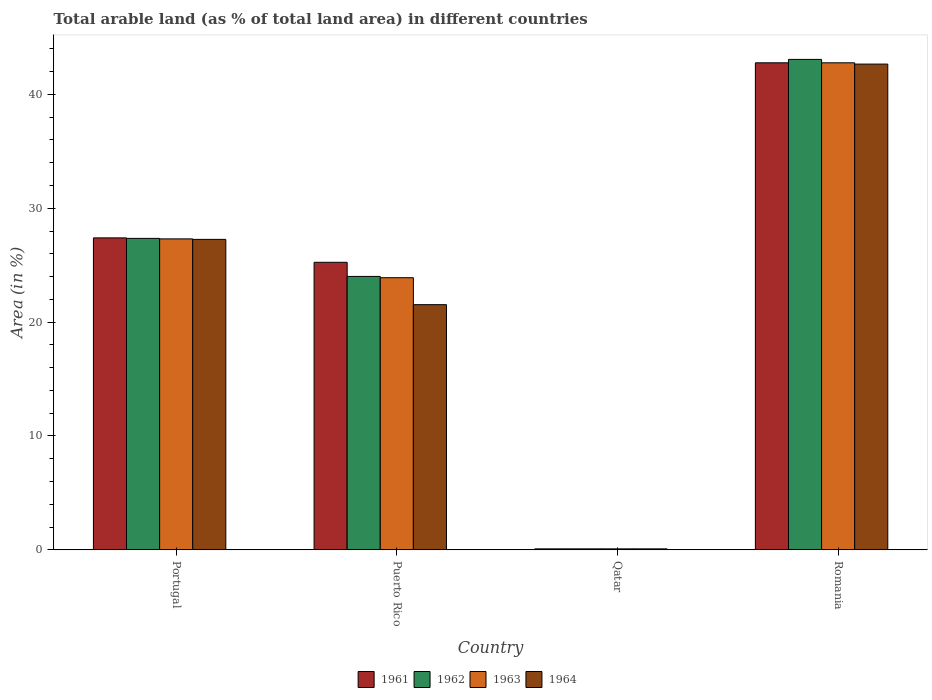How many different coloured bars are there?
Your answer should be compact. 4. How many groups of bars are there?
Provide a succinct answer. 4. Are the number of bars per tick equal to the number of legend labels?
Ensure brevity in your answer.  Yes. Are the number of bars on each tick of the X-axis equal?
Ensure brevity in your answer.  Yes. How many bars are there on the 1st tick from the left?
Give a very brief answer. 4. In how many cases, is the number of bars for a given country not equal to the number of legend labels?
Offer a terse response. 0. What is the percentage of arable land in 1963 in Puerto Rico?
Provide a succinct answer. 23.9. Across all countries, what is the maximum percentage of arable land in 1963?
Give a very brief answer. 42.78. Across all countries, what is the minimum percentage of arable land in 1964?
Give a very brief answer. 0.09. In which country was the percentage of arable land in 1963 maximum?
Your answer should be very brief. Romania. In which country was the percentage of arable land in 1964 minimum?
Offer a terse response. Qatar. What is the total percentage of arable land in 1963 in the graph?
Provide a short and direct response. 94.07. What is the difference between the percentage of arable land in 1962 in Portugal and that in Puerto Rico?
Your answer should be compact. 3.34. What is the difference between the percentage of arable land in 1961 in Puerto Rico and the percentage of arable land in 1963 in Portugal?
Provide a short and direct response. -2.06. What is the average percentage of arable land in 1963 per country?
Keep it short and to the point. 23.52. What is the difference between the percentage of arable land of/in 1961 and percentage of arable land of/in 1964 in Puerto Rico?
Make the answer very short. 3.72. In how many countries, is the percentage of arable land in 1963 greater than 34 %?
Offer a very short reply. 1. What is the ratio of the percentage of arable land in 1963 in Portugal to that in Qatar?
Your response must be concise. 317.09. Is the percentage of arable land in 1962 in Puerto Rico less than that in Qatar?
Your answer should be compact. No. Is the difference between the percentage of arable land in 1961 in Portugal and Romania greater than the difference between the percentage of arable land in 1964 in Portugal and Romania?
Give a very brief answer. Yes. What is the difference between the highest and the second highest percentage of arable land in 1963?
Provide a short and direct response. 15.46. What is the difference between the highest and the lowest percentage of arable land in 1963?
Provide a succinct answer. 42.69. In how many countries, is the percentage of arable land in 1962 greater than the average percentage of arable land in 1962 taken over all countries?
Give a very brief answer. 3. Is it the case that in every country, the sum of the percentage of arable land in 1964 and percentage of arable land in 1962 is greater than the sum of percentage of arable land in 1963 and percentage of arable land in 1961?
Keep it short and to the point. No. What does the 4th bar from the left in Qatar represents?
Your response must be concise. 1964. How many countries are there in the graph?
Ensure brevity in your answer.  4. What is the difference between two consecutive major ticks on the Y-axis?
Make the answer very short. 10. Are the values on the major ticks of Y-axis written in scientific E-notation?
Your answer should be compact. No. Does the graph contain any zero values?
Offer a terse response. No. Does the graph contain grids?
Keep it short and to the point. No. How are the legend labels stacked?
Offer a terse response. Horizontal. What is the title of the graph?
Make the answer very short. Total arable land (as % of total land area) in different countries. What is the label or title of the X-axis?
Your answer should be compact. Country. What is the label or title of the Y-axis?
Your response must be concise. Area (in %). What is the Area (in %) in 1961 in Portugal?
Give a very brief answer. 27.4. What is the Area (in %) in 1962 in Portugal?
Ensure brevity in your answer.  27.36. What is the Area (in %) of 1963 in Portugal?
Provide a short and direct response. 27.31. What is the Area (in %) of 1964 in Portugal?
Offer a terse response. 27.27. What is the Area (in %) in 1961 in Puerto Rico?
Provide a succinct answer. 25.25. What is the Area (in %) of 1962 in Puerto Rico?
Your response must be concise. 24.01. What is the Area (in %) of 1963 in Puerto Rico?
Offer a terse response. 23.9. What is the Area (in %) in 1964 in Puerto Rico?
Provide a succinct answer. 21.53. What is the Area (in %) of 1961 in Qatar?
Make the answer very short. 0.09. What is the Area (in %) of 1962 in Qatar?
Your answer should be compact. 0.09. What is the Area (in %) of 1963 in Qatar?
Keep it short and to the point. 0.09. What is the Area (in %) in 1964 in Qatar?
Provide a succinct answer. 0.09. What is the Area (in %) of 1961 in Romania?
Make the answer very short. 42.78. What is the Area (in %) of 1962 in Romania?
Provide a succinct answer. 43.08. What is the Area (in %) of 1963 in Romania?
Offer a terse response. 42.78. What is the Area (in %) of 1964 in Romania?
Your answer should be very brief. 42.66. Across all countries, what is the maximum Area (in %) in 1961?
Your answer should be compact. 42.78. Across all countries, what is the maximum Area (in %) in 1962?
Provide a short and direct response. 43.08. Across all countries, what is the maximum Area (in %) in 1963?
Offer a very short reply. 42.78. Across all countries, what is the maximum Area (in %) of 1964?
Keep it short and to the point. 42.66. Across all countries, what is the minimum Area (in %) in 1961?
Ensure brevity in your answer.  0.09. Across all countries, what is the minimum Area (in %) in 1962?
Provide a succinct answer. 0.09. Across all countries, what is the minimum Area (in %) in 1963?
Provide a succinct answer. 0.09. Across all countries, what is the minimum Area (in %) of 1964?
Provide a succinct answer. 0.09. What is the total Area (in %) of 1961 in the graph?
Your answer should be very brief. 95.51. What is the total Area (in %) in 1962 in the graph?
Make the answer very short. 94.53. What is the total Area (in %) in 1963 in the graph?
Make the answer very short. 94.07. What is the total Area (in %) in 1964 in the graph?
Your answer should be very brief. 91.55. What is the difference between the Area (in %) in 1961 in Portugal and that in Puerto Rico?
Make the answer very short. 2.15. What is the difference between the Area (in %) of 1962 in Portugal and that in Puerto Rico?
Offer a terse response. 3.34. What is the difference between the Area (in %) in 1963 in Portugal and that in Puerto Rico?
Make the answer very short. 3.41. What is the difference between the Area (in %) in 1964 in Portugal and that in Puerto Rico?
Provide a succinct answer. 5.73. What is the difference between the Area (in %) of 1961 in Portugal and that in Qatar?
Keep it short and to the point. 27.31. What is the difference between the Area (in %) of 1962 in Portugal and that in Qatar?
Your answer should be very brief. 27.27. What is the difference between the Area (in %) in 1963 in Portugal and that in Qatar?
Offer a terse response. 27.23. What is the difference between the Area (in %) in 1964 in Portugal and that in Qatar?
Ensure brevity in your answer.  27.18. What is the difference between the Area (in %) of 1961 in Portugal and that in Romania?
Your response must be concise. -15.38. What is the difference between the Area (in %) in 1962 in Portugal and that in Romania?
Offer a very short reply. -15.72. What is the difference between the Area (in %) in 1963 in Portugal and that in Romania?
Offer a very short reply. -15.46. What is the difference between the Area (in %) in 1964 in Portugal and that in Romania?
Your answer should be very brief. -15.4. What is the difference between the Area (in %) of 1961 in Puerto Rico and that in Qatar?
Ensure brevity in your answer.  25.17. What is the difference between the Area (in %) in 1962 in Puerto Rico and that in Qatar?
Give a very brief answer. 23.93. What is the difference between the Area (in %) of 1963 in Puerto Rico and that in Qatar?
Give a very brief answer. 23.81. What is the difference between the Area (in %) of 1964 in Puerto Rico and that in Qatar?
Make the answer very short. 21.45. What is the difference between the Area (in %) in 1961 in Puerto Rico and that in Romania?
Provide a short and direct response. -17.52. What is the difference between the Area (in %) in 1962 in Puerto Rico and that in Romania?
Your answer should be very brief. -19.06. What is the difference between the Area (in %) in 1963 in Puerto Rico and that in Romania?
Offer a terse response. -18.88. What is the difference between the Area (in %) of 1964 in Puerto Rico and that in Romania?
Your answer should be compact. -21.13. What is the difference between the Area (in %) of 1961 in Qatar and that in Romania?
Ensure brevity in your answer.  -42.69. What is the difference between the Area (in %) of 1962 in Qatar and that in Romania?
Your answer should be compact. -42.99. What is the difference between the Area (in %) in 1963 in Qatar and that in Romania?
Offer a very short reply. -42.69. What is the difference between the Area (in %) of 1964 in Qatar and that in Romania?
Give a very brief answer. -42.58. What is the difference between the Area (in %) in 1961 in Portugal and the Area (in %) in 1962 in Puerto Rico?
Your answer should be compact. 3.39. What is the difference between the Area (in %) of 1961 in Portugal and the Area (in %) of 1963 in Puerto Rico?
Make the answer very short. 3.5. What is the difference between the Area (in %) of 1961 in Portugal and the Area (in %) of 1964 in Puerto Rico?
Make the answer very short. 5.87. What is the difference between the Area (in %) of 1962 in Portugal and the Area (in %) of 1963 in Puerto Rico?
Give a very brief answer. 3.45. What is the difference between the Area (in %) in 1962 in Portugal and the Area (in %) in 1964 in Puerto Rico?
Your response must be concise. 5.82. What is the difference between the Area (in %) in 1963 in Portugal and the Area (in %) in 1964 in Puerto Rico?
Your answer should be very brief. 5.78. What is the difference between the Area (in %) of 1961 in Portugal and the Area (in %) of 1962 in Qatar?
Keep it short and to the point. 27.31. What is the difference between the Area (in %) in 1961 in Portugal and the Area (in %) in 1963 in Qatar?
Provide a short and direct response. 27.31. What is the difference between the Area (in %) in 1961 in Portugal and the Area (in %) in 1964 in Qatar?
Your answer should be compact. 27.31. What is the difference between the Area (in %) in 1962 in Portugal and the Area (in %) in 1963 in Qatar?
Your answer should be compact. 27.27. What is the difference between the Area (in %) of 1962 in Portugal and the Area (in %) of 1964 in Qatar?
Your answer should be compact. 27.27. What is the difference between the Area (in %) in 1963 in Portugal and the Area (in %) in 1964 in Qatar?
Provide a short and direct response. 27.23. What is the difference between the Area (in %) in 1961 in Portugal and the Area (in %) in 1962 in Romania?
Keep it short and to the point. -15.68. What is the difference between the Area (in %) of 1961 in Portugal and the Area (in %) of 1963 in Romania?
Your answer should be very brief. -15.38. What is the difference between the Area (in %) of 1961 in Portugal and the Area (in %) of 1964 in Romania?
Provide a short and direct response. -15.26. What is the difference between the Area (in %) in 1962 in Portugal and the Area (in %) in 1963 in Romania?
Offer a very short reply. -15.42. What is the difference between the Area (in %) in 1962 in Portugal and the Area (in %) in 1964 in Romania?
Your answer should be very brief. -15.31. What is the difference between the Area (in %) of 1963 in Portugal and the Area (in %) of 1964 in Romania?
Give a very brief answer. -15.35. What is the difference between the Area (in %) of 1961 in Puerto Rico and the Area (in %) of 1962 in Qatar?
Give a very brief answer. 25.17. What is the difference between the Area (in %) in 1961 in Puerto Rico and the Area (in %) in 1963 in Qatar?
Make the answer very short. 25.17. What is the difference between the Area (in %) in 1961 in Puerto Rico and the Area (in %) in 1964 in Qatar?
Give a very brief answer. 25.17. What is the difference between the Area (in %) in 1962 in Puerto Rico and the Area (in %) in 1963 in Qatar?
Your answer should be compact. 23.93. What is the difference between the Area (in %) in 1962 in Puerto Rico and the Area (in %) in 1964 in Qatar?
Provide a succinct answer. 23.93. What is the difference between the Area (in %) of 1963 in Puerto Rico and the Area (in %) of 1964 in Qatar?
Offer a terse response. 23.81. What is the difference between the Area (in %) in 1961 in Puerto Rico and the Area (in %) in 1962 in Romania?
Your answer should be very brief. -17.82. What is the difference between the Area (in %) of 1961 in Puerto Rico and the Area (in %) of 1963 in Romania?
Offer a terse response. -17.52. What is the difference between the Area (in %) in 1961 in Puerto Rico and the Area (in %) in 1964 in Romania?
Make the answer very short. -17.41. What is the difference between the Area (in %) of 1962 in Puerto Rico and the Area (in %) of 1963 in Romania?
Ensure brevity in your answer.  -18.76. What is the difference between the Area (in %) of 1962 in Puerto Rico and the Area (in %) of 1964 in Romania?
Provide a succinct answer. -18.65. What is the difference between the Area (in %) of 1963 in Puerto Rico and the Area (in %) of 1964 in Romania?
Your answer should be very brief. -18.76. What is the difference between the Area (in %) in 1961 in Qatar and the Area (in %) in 1962 in Romania?
Your answer should be very brief. -42.99. What is the difference between the Area (in %) in 1961 in Qatar and the Area (in %) in 1963 in Romania?
Keep it short and to the point. -42.69. What is the difference between the Area (in %) of 1961 in Qatar and the Area (in %) of 1964 in Romania?
Make the answer very short. -42.58. What is the difference between the Area (in %) of 1962 in Qatar and the Area (in %) of 1963 in Romania?
Your answer should be compact. -42.69. What is the difference between the Area (in %) of 1962 in Qatar and the Area (in %) of 1964 in Romania?
Make the answer very short. -42.58. What is the difference between the Area (in %) of 1963 in Qatar and the Area (in %) of 1964 in Romania?
Give a very brief answer. -42.58. What is the average Area (in %) in 1961 per country?
Offer a terse response. 23.88. What is the average Area (in %) of 1962 per country?
Offer a very short reply. 23.63. What is the average Area (in %) of 1963 per country?
Your answer should be very brief. 23.52. What is the average Area (in %) of 1964 per country?
Make the answer very short. 22.89. What is the difference between the Area (in %) in 1961 and Area (in %) in 1962 in Portugal?
Your answer should be compact. 0.04. What is the difference between the Area (in %) of 1961 and Area (in %) of 1963 in Portugal?
Ensure brevity in your answer.  0.09. What is the difference between the Area (in %) of 1961 and Area (in %) of 1964 in Portugal?
Your answer should be compact. 0.13. What is the difference between the Area (in %) of 1962 and Area (in %) of 1963 in Portugal?
Provide a succinct answer. 0.04. What is the difference between the Area (in %) in 1962 and Area (in %) in 1964 in Portugal?
Ensure brevity in your answer.  0.09. What is the difference between the Area (in %) in 1963 and Area (in %) in 1964 in Portugal?
Keep it short and to the point. 0.04. What is the difference between the Area (in %) in 1961 and Area (in %) in 1962 in Puerto Rico?
Provide a short and direct response. 1.24. What is the difference between the Area (in %) of 1961 and Area (in %) of 1963 in Puerto Rico?
Ensure brevity in your answer.  1.35. What is the difference between the Area (in %) of 1961 and Area (in %) of 1964 in Puerto Rico?
Your answer should be compact. 3.72. What is the difference between the Area (in %) of 1962 and Area (in %) of 1963 in Puerto Rico?
Your response must be concise. 0.11. What is the difference between the Area (in %) in 1962 and Area (in %) in 1964 in Puerto Rico?
Your answer should be very brief. 2.48. What is the difference between the Area (in %) in 1963 and Area (in %) in 1964 in Puerto Rico?
Your response must be concise. 2.37. What is the difference between the Area (in %) of 1961 and Area (in %) of 1963 in Qatar?
Your answer should be compact. 0. What is the difference between the Area (in %) of 1962 and Area (in %) of 1963 in Qatar?
Offer a terse response. 0. What is the difference between the Area (in %) in 1962 and Area (in %) in 1964 in Qatar?
Offer a terse response. 0. What is the difference between the Area (in %) of 1963 and Area (in %) of 1964 in Qatar?
Your answer should be compact. 0. What is the difference between the Area (in %) in 1961 and Area (in %) in 1962 in Romania?
Provide a short and direct response. -0.3. What is the difference between the Area (in %) of 1961 and Area (in %) of 1964 in Romania?
Provide a short and direct response. 0.11. What is the difference between the Area (in %) in 1962 and Area (in %) in 1963 in Romania?
Make the answer very short. 0.3. What is the difference between the Area (in %) of 1962 and Area (in %) of 1964 in Romania?
Ensure brevity in your answer.  0.41. What is the difference between the Area (in %) in 1963 and Area (in %) in 1964 in Romania?
Make the answer very short. 0.11. What is the ratio of the Area (in %) of 1961 in Portugal to that in Puerto Rico?
Offer a terse response. 1.08. What is the ratio of the Area (in %) in 1962 in Portugal to that in Puerto Rico?
Give a very brief answer. 1.14. What is the ratio of the Area (in %) of 1963 in Portugal to that in Puerto Rico?
Give a very brief answer. 1.14. What is the ratio of the Area (in %) of 1964 in Portugal to that in Puerto Rico?
Provide a short and direct response. 1.27. What is the ratio of the Area (in %) in 1961 in Portugal to that in Qatar?
Make the answer very short. 318.1. What is the ratio of the Area (in %) of 1962 in Portugal to that in Qatar?
Ensure brevity in your answer.  317.59. What is the ratio of the Area (in %) in 1963 in Portugal to that in Qatar?
Provide a short and direct response. 317.09. What is the ratio of the Area (in %) in 1964 in Portugal to that in Qatar?
Your answer should be compact. 316.58. What is the ratio of the Area (in %) in 1961 in Portugal to that in Romania?
Offer a terse response. 0.64. What is the ratio of the Area (in %) of 1962 in Portugal to that in Romania?
Ensure brevity in your answer.  0.64. What is the ratio of the Area (in %) of 1963 in Portugal to that in Romania?
Keep it short and to the point. 0.64. What is the ratio of the Area (in %) in 1964 in Portugal to that in Romania?
Offer a very short reply. 0.64. What is the ratio of the Area (in %) in 1961 in Puerto Rico to that in Qatar?
Offer a very short reply. 293.19. What is the ratio of the Area (in %) in 1962 in Puerto Rico to that in Qatar?
Your response must be concise. 278.8. What is the ratio of the Area (in %) in 1963 in Puerto Rico to that in Qatar?
Ensure brevity in your answer.  277.49. What is the ratio of the Area (in %) in 1964 in Puerto Rico to that in Qatar?
Make the answer very short. 250. What is the ratio of the Area (in %) in 1961 in Puerto Rico to that in Romania?
Your answer should be compact. 0.59. What is the ratio of the Area (in %) of 1962 in Puerto Rico to that in Romania?
Your answer should be compact. 0.56. What is the ratio of the Area (in %) in 1963 in Puerto Rico to that in Romania?
Give a very brief answer. 0.56. What is the ratio of the Area (in %) in 1964 in Puerto Rico to that in Romania?
Your answer should be very brief. 0.5. What is the ratio of the Area (in %) in 1961 in Qatar to that in Romania?
Offer a very short reply. 0. What is the ratio of the Area (in %) in 1962 in Qatar to that in Romania?
Your answer should be compact. 0. What is the ratio of the Area (in %) of 1963 in Qatar to that in Romania?
Provide a succinct answer. 0. What is the ratio of the Area (in %) of 1964 in Qatar to that in Romania?
Ensure brevity in your answer.  0. What is the difference between the highest and the second highest Area (in %) of 1961?
Provide a succinct answer. 15.38. What is the difference between the highest and the second highest Area (in %) in 1962?
Your response must be concise. 15.72. What is the difference between the highest and the second highest Area (in %) of 1963?
Offer a very short reply. 15.46. What is the difference between the highest and the second highest Area (in %) in 1964?
Provide a succinct answer. 15.4. What is the difference between the highest and the lowest Area (in %) in 1961?
Offer a very short reply. 42.69. What is the difference between the highest and the lowest Area (in %) of 1962?
Your answer should be compact. 42.99. What is the difference between the highest and the lowest Area (in %) of 1963?
Your response must be concise. 42.69. What is the difference between the highest and the lowest Area (in %) of 1964?
Offer a terse response. 42.58. 